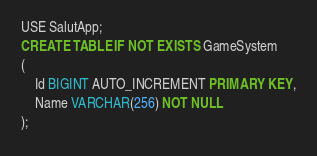<code> <loc_0><loc_0><loc_500><loc_500><_SQL_>USE SalutApp;
CREATE TABLE IF NOT EXISTS GameSystem
(
    Id BIGINT AUTO_INCREMENT PRIMARY KEY,
    Name VARCHAR(256) NOT NULL
);</code> 